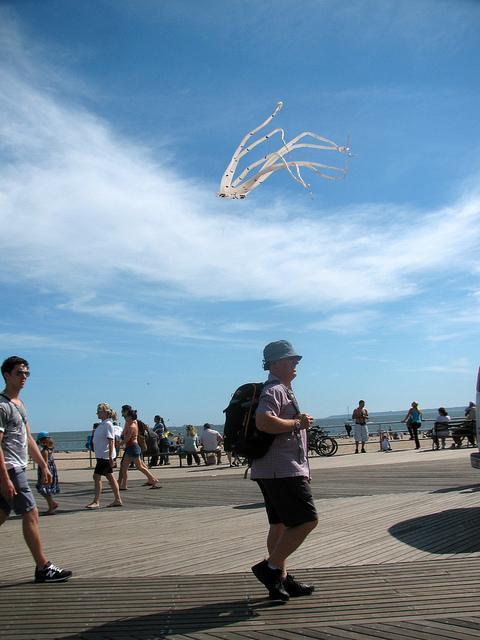How many kites are there?
Give a very brief answer. 1. How many people can you see?
Give a very brief answer. 3. How many red cars are in the picture?
Give a very brief answer. 0. 